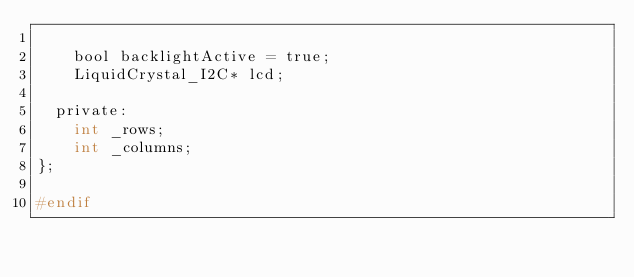Convert code to text. <code><loc_0><loc_0><loc_500><loc_500><_C_>
    bool backlightActive = true;
    LiquidCrystal_I2C* lcd;

  private:
    int _rows;
    int _columns;
};

#endif
</code> 